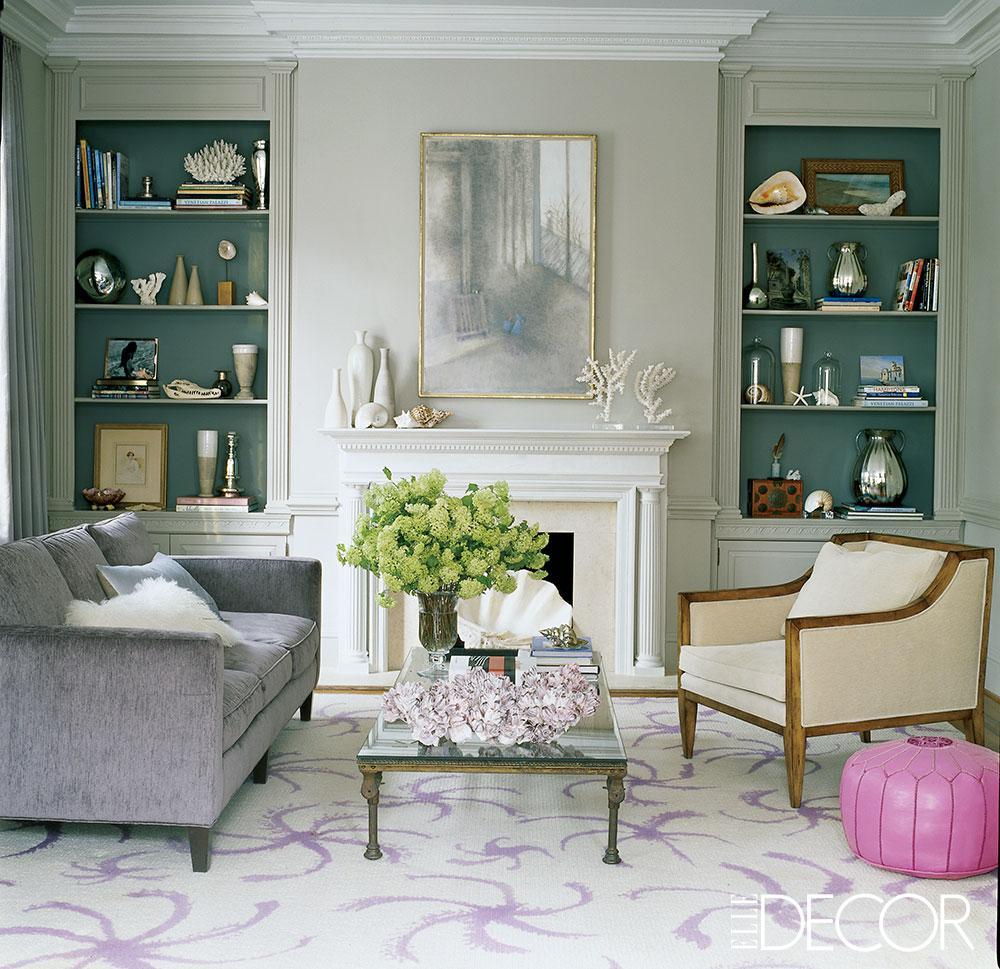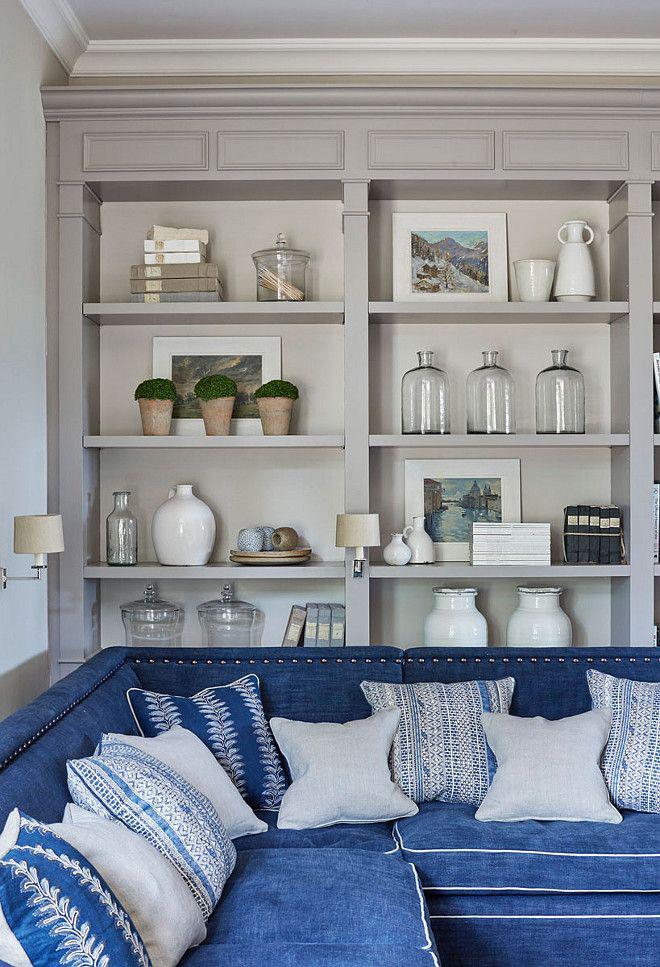The first image is the image on the left, the second image is the image on the right. Evaluate the accuracy of this statement regarding the images: "In one image, floor to ceiling shelving units topped with crown molding flank a fire place and mantle.". Is it true? Answer yes or no. Yes. 